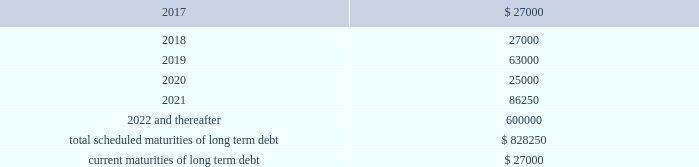Be adjusted by reference to a grid ( the 201cpricing grid 201d ) based on the consolidated leverage ratio and ranges between 1.00% ( 1.00 % ) to 1.25% ( 1.25 % ) for adjusted libor loans and 0.00% ( 0.00 % ) to 0.25% ( 0.25 % ) for alternate base rate loans .
The weighted average interest rate under the outstanding term loans and revolving credit facility borrowings was 1.6% ( 1.6 % ) and 1.3% ( 1.3 % ) during the years ended december 31 , 2016 and 2015 , respectively .
The company pays a commitment fee on the average daily unused amount of the revolving credit facility and certain fees with respect to letters of credit .
As of december 31 , 2016 , the commitment fee was 15.0 basis points .
Since inception , the company incurred and deferred $ 3.9 million in financing costs in connection with the credit agreement .
3.250% ( 3.250 % ) senior notes in june 2016 , the company issued $ 600.0 million aggregate principal amount of 3.250% ( 3.250 % ) senior unsecured notes due june 15 , 2026 ( the 201cnotes 201d ) .
The proceeds were used to pay down amounts outstanding under the revolving credit facility .
Interest is payable semi-annually on june 15 and december 15 beginning december 15 , 2016 .
Prior to march 15 , 2026 ( three months prior to the maturity date of the notes ) , the company may redeem some or all of the notes at any time or from time to time at a redemption price equal to the greater of 100% ( 100 % ) of the principal amount of the notes to be redeemed or a 201cmake-whole 201d amount applicable to such notes as described in the indenture governing the notes , plus accrued and unpaid interest to , but excluding , the redemption date .
On or after march 15 , 2026 ( three months prior to the maturity date of the notes ) , the company may redeem some or all of the notes at any time or from time to time at a redemption price equal to 100% ( 100 % ) of the principal amount of the notes to be redeemed , plus accrued and unpaid interest to , but excluding , the redemption date .
The indenture governing the notes contains covenants , including limitations that restrict the company 2019s ability and the ability of certain of its subsidiaries to create or incur secured indebtedness and enter into sale and leaseback transactions and the company 2019s ability to consolidate , merge or transfer all or substantially all of its properties or assets to another person , in each case subject to material exceptions described in the indenture .
The company incurred and deferred $ 5.3 million in financing costs in connection with the notes .
Other long term debt in december 2012 , the company entered into a $ 50.0 million recourse loan collateralized by the land , buildings and tenant improvements comprising the company 2019s corporate headquarters .
The loan has a seven year term and maturity date of december 2019 .
The loan bears interest at one month libor plus a margin of 1.50% ( 1.50 % ) , and allows for prepayment without penalty .
The loan includes covenants and events of default substantially consistent with the company 2019s credit agreement discussed above .
The loan also requires prior approval of the lender for certain matters related to the property , including transfers of any interest in the property .
As of december 31 , 2016 and 2015 , the outstanding balance on the loan was $ 42.0 million and $ 44.0 million , respectively .
The weighted average interest rate on the loan was 2.0% ( 2.0 % ) and 1.7% ( 1.7 % ) for the years ended december 31 , 2016 and 2015 , respectively .
The following are the scheduled maturities of long term debt as of december 31 , 2016 : ( in thousands ) .

What percentage of total scheduled maturities of long term debt are due in 2019? 
Computations: (63000 / 828250)
Answer: 0.07606. 